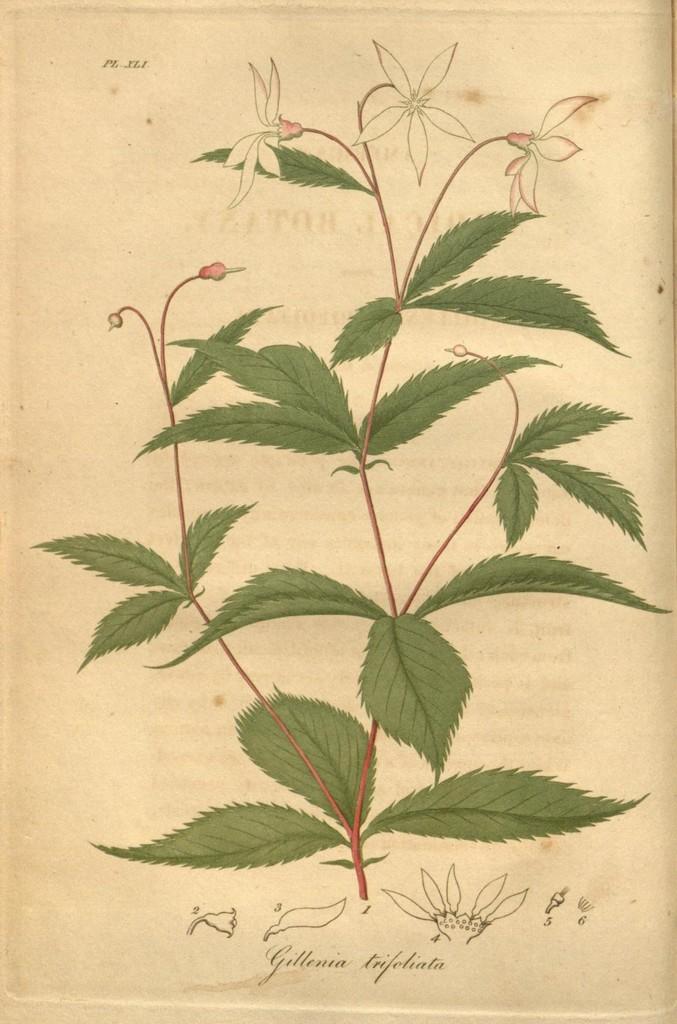In one or two sentences, can you explain what this image depicts? This is a paper. On that there is a painting of a plant with flowers and also something is written on that 